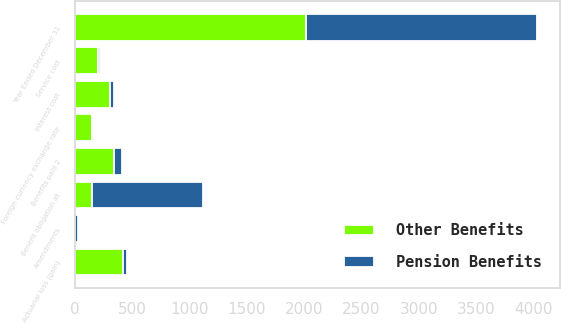Convert chart to OTSL. <chart><loc_0><loc_0><loc_500><loc_500><stacked_bar_chart><ecel><fcel>Year Ended December 31<fcel>Benefit obligation at<fcel>Service cost<fcel>Interest cost<fcel>Foreign currency exchange rate<fcel>Amendments<fcel>Actuarial loss (gain)<fcel>Benefits paid 2<nl><fcel>Other Benefits<fcel>2017<fcel>150<fcel>197<fcel>306<fcel>150<fcel>1<fcel>420<fcel>341<nl><fcel>Pension Benefits<fcel>2017<fcel>962<fcel>17<fcel>29<fcel>4<fcel>21<fcel>28<fcel>71<nl></chart> 